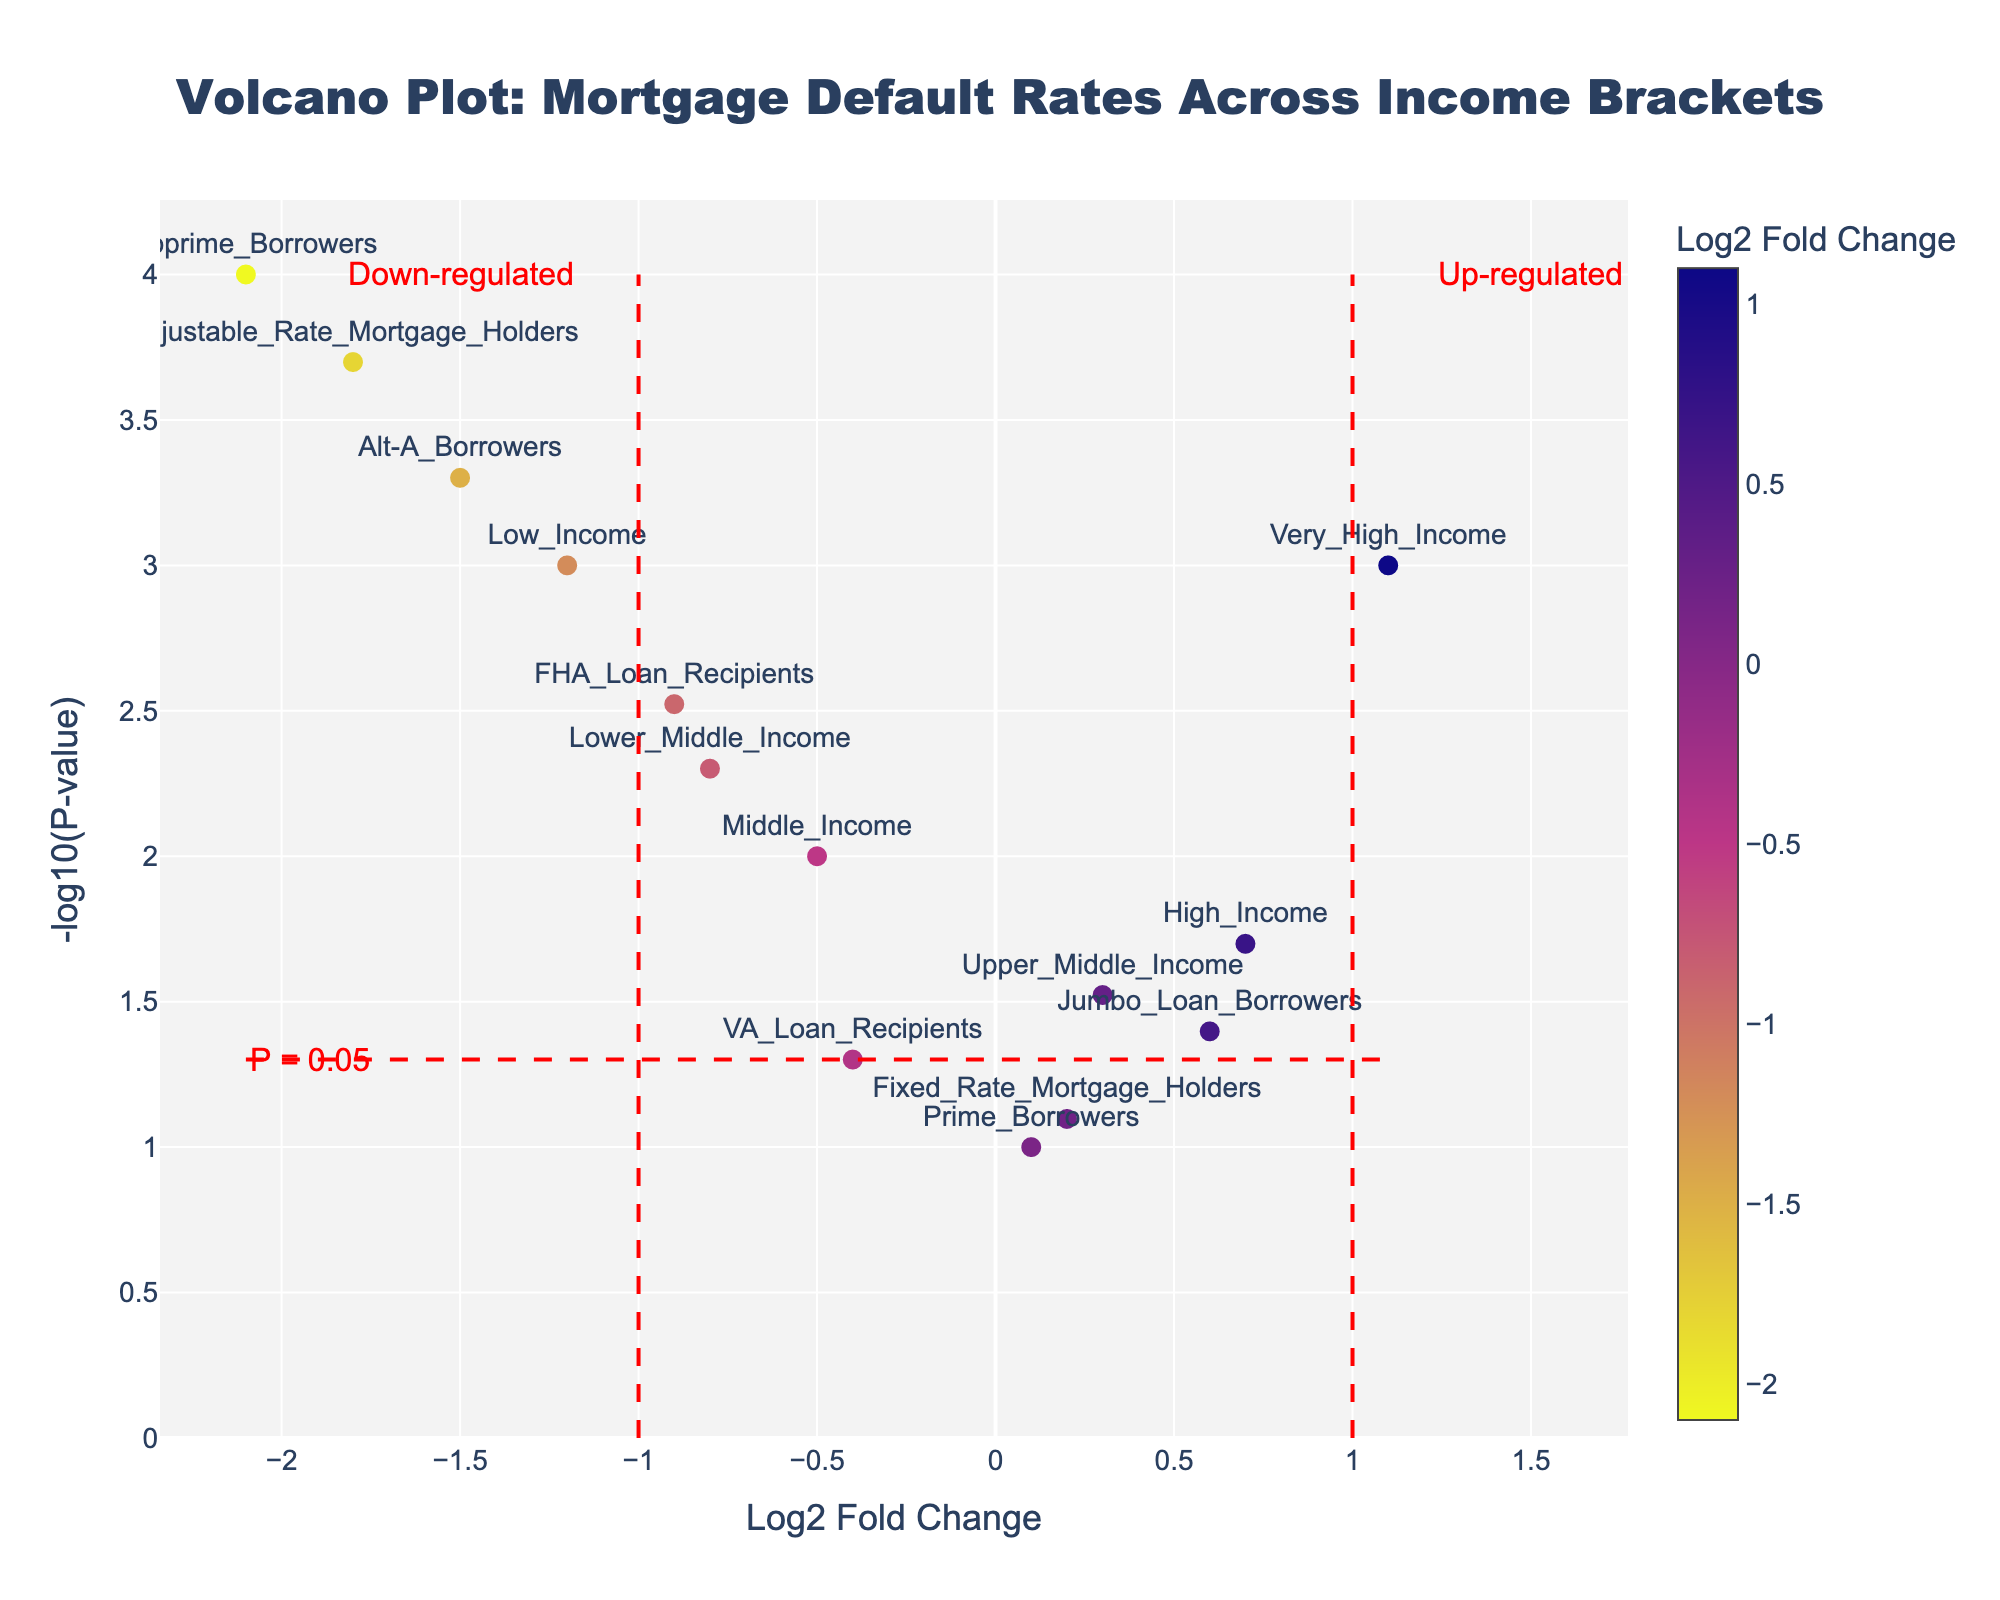What is the title of the plot? The title of the plot is located at the top and reads "Volcano Plot: Mortgage Default Rates Across Income Brackets".
Answer: Volcano Plot: Mortgage Default Rates Across Income Brackets Which income bracket experienced the highest decrease in default rates? The scatter point farthest to the left on the x-axis represents the income bracket with the highest decrease in default rates. This point is labeled "Subprime_Borrowers" with a Log2 Fold Change of -2.1.
Answer: Subprime_Borrowers What does a higher value on the y-axis represent? On the y-axis, higher values indicate a smaller p-value because the y-axis represents the negative logarithm of the p-value (-log10(P-value)), making higher positions signify higher statistical significance.
Answer: Smaller p-value (higher statistical significance) Which income bracket experienced the highest increase in default rates? Look for the scatter point farthest to the right on the x-axis. This data point is labeled "Very_High_Income" with a Log2 Fold Change of 1.1.
Answer: Very_High_Income What does a negative Log2 Fold Change signify in this plot? In the plot, a negative Log2 Fold Change signifies a decrease in default rates post-crisis compared to pre-crisis.
Answer: Decrease in default rates How many income brackets show a significant change in default rates (P-value < 0.05)? Counting the data points above the horizontal dashed line (P = 0.05) in the plot, there are 10 income brackets that show a significant change in default rates.
Answer: 10 Which types of mortgage holders are situated on the left half of the plot (Log2 Fold Change < 0)? Observing the left side of the plot, the mortgage holders situated there include Low_Income, Lower_Middle_Income, Middle_Income, Subprime_Borrowers, Alt-A_Borrowers, FHA_Loan_Recipients, and Adjustable_Rate_Mortgage_Holders.
Answer: Low_Income, Lower_Middle_Income, Middle_Income, Subprime_Borrowers, Alt-A_Borrowers, FHA_Loan_Recipients, Adjustable_Rate_Mortgage_Holders What does the red horizontal dashed line signify in the plot? The red horizontal dashed line is labeled with "P = 0.05", indicating the p-value threshold for statistical significance, where points above this line are considered statistically significant with p-values less than 0.05.
Answer: P-value threshold of 0.05 How is the information about income brackets displayed in the plot? The information about income brackets is displayed as text labels next to each scatter point, and also appears as hover text when hovering over the points.
Answer: Text labels and hover text Which markers in the plot have the smallest p-values? Markers with the highest y-axis values represent the smallest p-values. These include Subprime_Borrowers, Very_High_Income, and Adjustable_Rate_Mortgage_Holders, as denoted by their position at the top of the plot.
Answer: Subprime_Borrowers, Very_High_Income, Adjustable_Rate_Mortgage_Holders 